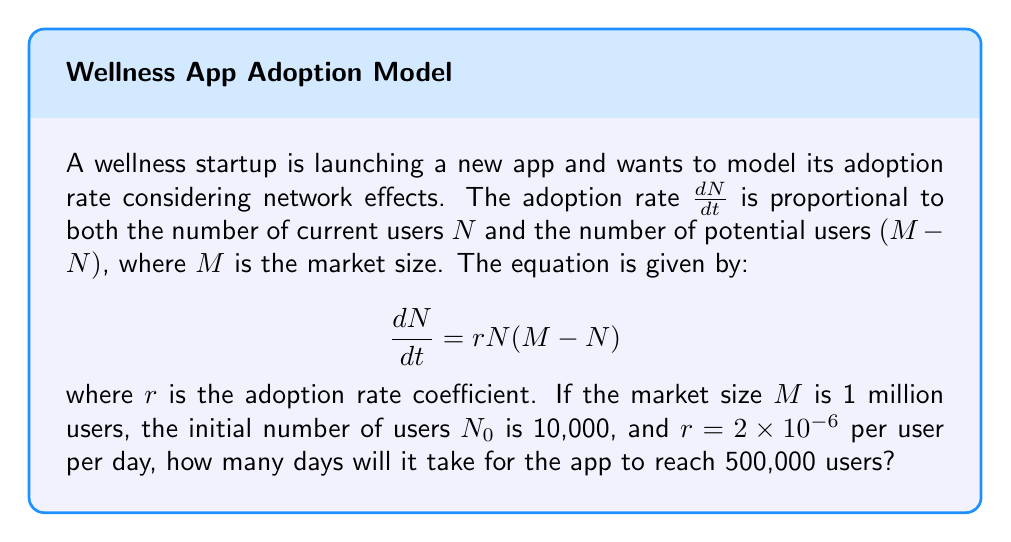Provide a solution to this math problem. To solve this problem, we need to integrate the differential equation and solve for time $t$. The steps are as follows:

1) First, separate the variables:

   $$\frac{dN}{N(M-N)} = rdt$$

2) Integrate both sides:

   $$\int_{N_0}^N \frac{dN}{N(M-N)} = \int_0^t rdt$$

3) The left-hand side can be integrated using partial fractions:

   $$\left[\frac{1}{M}\ln\left(\frac{N}{M-N}\right)\right]_{N_0}^N = rt$$

4) Evaluate the definite integral:

   $$\frac{1}{M}\ln\left(\frac{N}{M-N}\right) - \frac{1}{M}\ln\left(\frac{N_0}{M-N_0}\right) = rt$$

5) Simplify and solve for $t$:

   $$t = \frac{1}{rM}\ln\left(\frac{N(M-N_0)}{N_0(M-N)}\right)$$

6) Now substitute the given values:
   $M = 1,000,000$
   $N_0 = 10,000$
   $N = 500,000$ (target number of users)
   $r = 2 \times 10^{-6}$

   $$t = \frac{1}{(2 \times 10^{-6})(1,000,000)}\ln\left(\frac{500,000(1,000,000-10,000)}{10,000(1,000,000-500,000)}\right)$$

7) Simplify:

   $$t = 500,000 \ln\left(\frac{500,000 \times 990,000}{10,000 \times 500,000}\right) = 500,000 \ln(99)$$

8) Calculate the final result:

   $$t \approx 2,302,585 \text{ days}$$
Answer: It will take approximately 2,302,585 days (about 6,309 years) for the app to reach 500,000 users. 